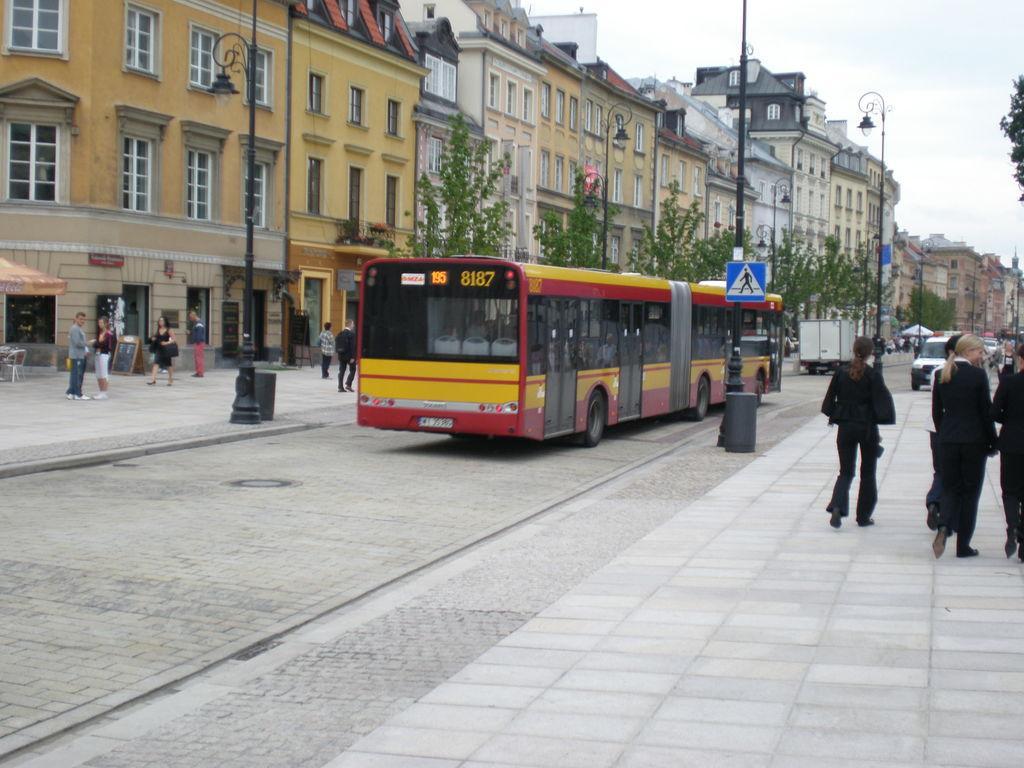In one or two sentences, can you explain what this image depicts? In this image, there is a bus beside the pole. There are some persons on the right side of the image standing and wearing clothes. There are some trees beside buildings. There is a sky in the top right of the image. 